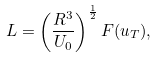<formula> <loc_0><loc_0><loc_500><loc_500>L = \left ( \frac { R ^ { 3 } } { U _ { 0 } } \right ) ^ { \frac { 1 } { 2 } } F ( u _ { T } ) ,</formula> 